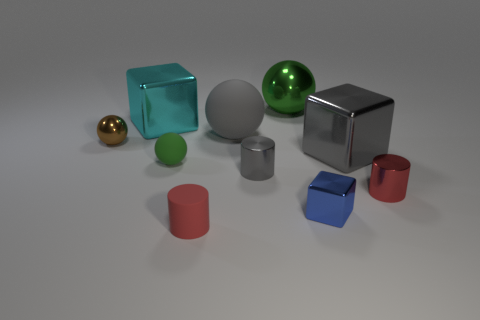What size is the thing that is the same color as the big shiny sphere?
Your answer should be compact. Small. How many metal blocks are both on the left side of the gray cube and to the right of the small red matte cylinder?
Your answer should be very brief. 1. The cyan cube that is made of the same material as the small gray cylinder is what size?
Make the answer very short. Large. There is a small thing that is on the left side of the big green sphere and in front of the small gray thing; what is its shape?
Offer a very short reply. Cylinder. Does the green metallic sphere have the same size as the red shiny thing?
Give a very brief answer. No. What number of small objects are to the left of the gray matte thing?
Offer a very short reply. 3. Are there an equal number of green things that are on the left side of the green metal thing and big gray balls that are to the left of the small matte cylinder?
Provide a succinct answer. No. There is a tiny rubber object in front of the small green ball; is its shape the same as the brown metallic object?
Make the answer very short. No. Is there any other thing that is made of the same material as the small blue object?
Offer a terse response. Yes. Do the gray sphere and the red object that is to the right of the small shiny cube have the same size?
Offer a very short reply. No. 